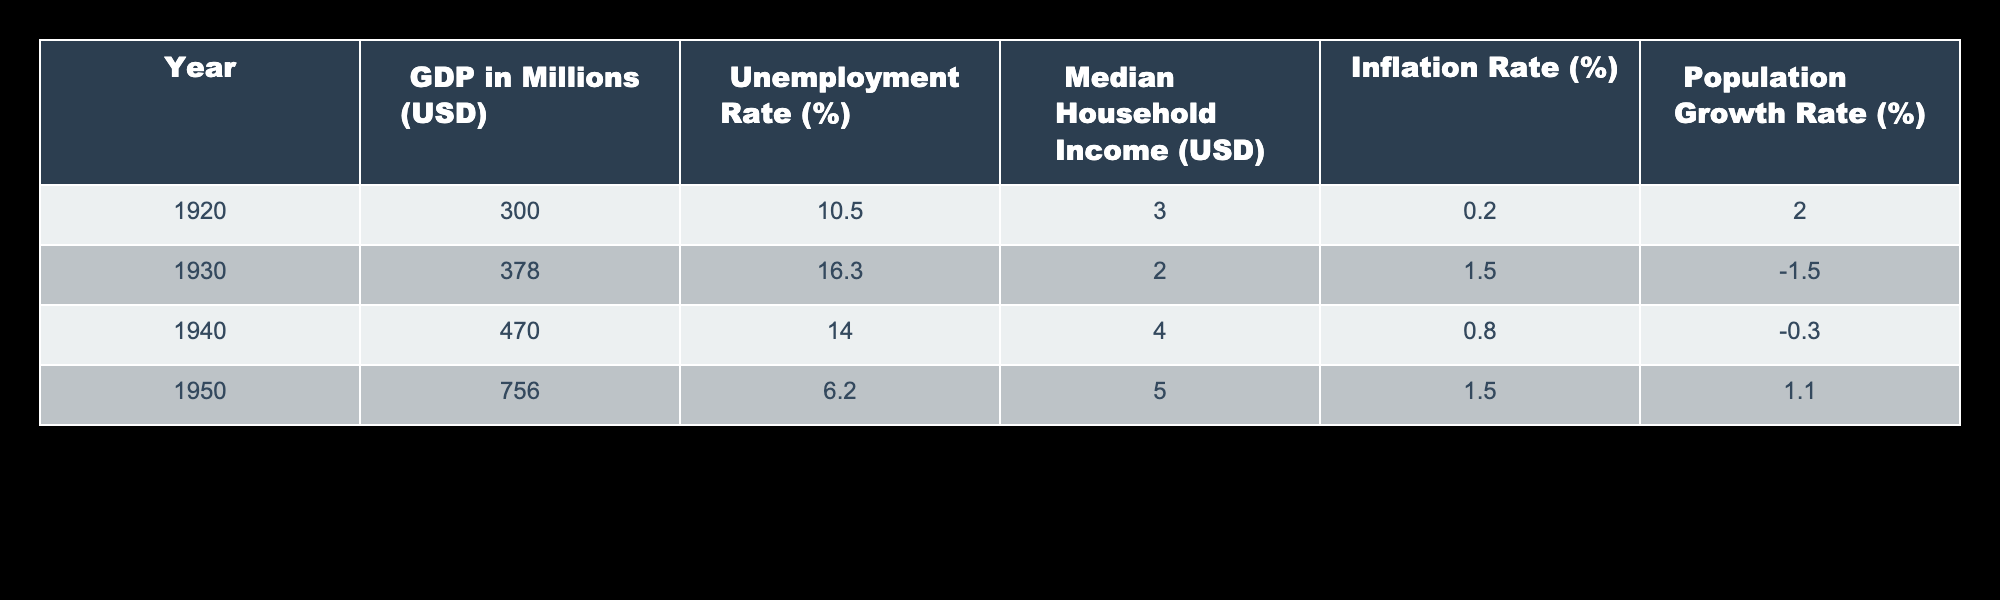What was the GDP in Kansas City in 1950? The table allows us to find the specific value for GDP in the year 1950. Looking at the corresponding row, the GDP in millions (USD) for that year is 756.
Answer: 756 What was the unemployment rate in 1940? To find the unemployment rate in 1940, we refer to the table and locate the entry for that year, which shows the unemployment rate as 14.0%.
Answer: 14.0% What was the average inflation rate between 1920 and 1950? First, we identify the inflation rates for the years 1920 (0.2%), 1930 (1.5%), 1940 (0.8%), and 1950 (1.5%). Next, we sum these values: 0.2 + 1.5 + 0.8 + 1.5 = 4.0%. Then we divide by the number of years, which is 4: 4.0% / 4 = 1.0%.
Answer: 1.0% Did the median household income increase from 1930 to 1950? By examining the table, we see that the median household income in 1930 is 2 USD and in 1950 it is 5 USD. Hence, comparing these values reveals that it increased.
Answer: Yes What was the population growth rate during the 1930s, and was it positive or negative? To determine the population growth rate during the 1930s, we look at the values for 1930 (-1.5%) and 1940 (-0.3%). As both values are negative, this indicates a negative population growth during this decade.
Answer: Negative What was the change in unemployment rate from 1950 to 1940? The unemployment rate for 1950 is 6.2% while for 1940, it is 14.0%. To find the change, we subtract: 6.2% - 14.0% = -7.8%. This indicates a decrease in the unemployment rate.
Answer: Decrease of 7.8% What is the median household income for the year with the highest unemployment rate? Looking through the table, the highest unemployment rate is 16.3% in 1930. The corresponding median household income for that year is 2 USD.
Answer: 2 Was the GDP in 1920 higher than the median household income in 1950? In 1920, the GDP was 300 million USD, while the median household income in 1950 was 5 USD. Clearly, 300 million USD is much greater than 5 USD, so the answer is yes.
Answer: Yes What was the median household income change from 1920 to 1940? The median household income in 1920 is 3 USD, and in 1940 it is 4 USD. To calculate the change, we subtract: 4 USD - 3 USD = 1 USD. Therefore, the median household income increased by 1 USD.
Answer: Increase of 1 USD 